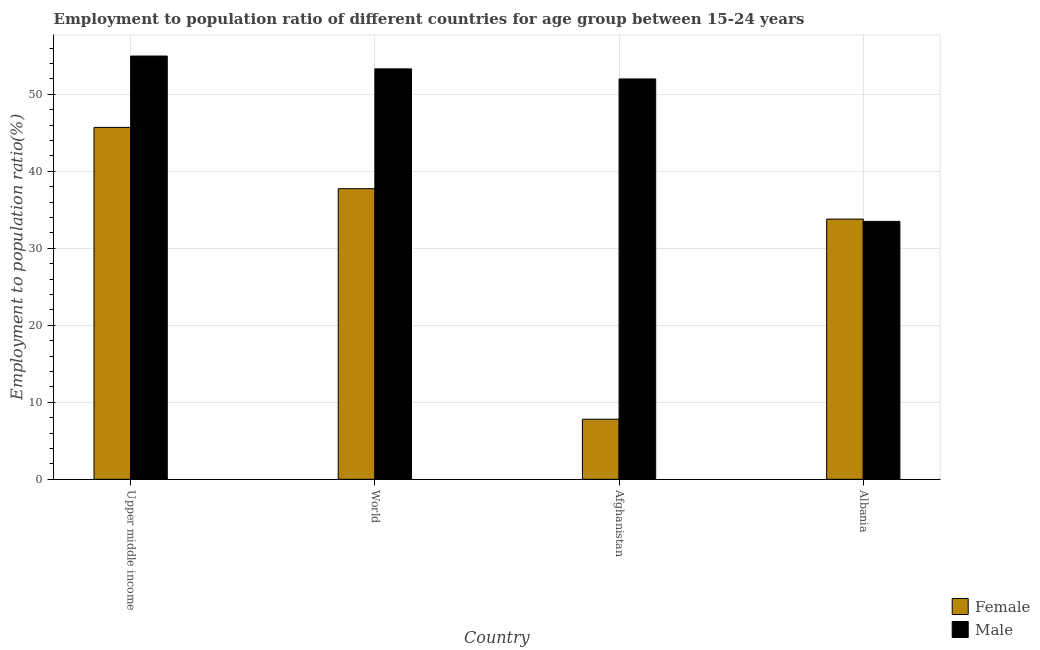How many groups of bars are there?
Make the answer very short. 4. Are the number of bars per tick equal to the number of legend labels?
Your answer should be very brief. Yes. How many bars are there on the 4th tick from the right?
Offer a terse response. 2. What is the label of the 3rd group of bars from the left?
Offer a terse response. Afghanistan. What is the employment to population ratio(male) in Afghanistan?
Ensure brevity in your answer.  52. Across all countries, what is the maximum employment to population ratio(female)?
Keep it short and to the point. 45.71. Across all countries, what is the minimum employment to population ratio(female)?
Your answer should be very brief. 7.8. In which country was the employment to population ratio(female) maximum?
Keep it short and to the point. Upper middle income. In which country was the employment to population ratio(male) minimum?
Offer a terse response. Albania. What is the total employment to population ratio(female) in the graph?
Your answer should be compact. 125.05. What is the difference between the employment to population ratio(female) in Afghanistan and that in Albania?
Offer a terse response. -26. What is the difference between the employment to population ratio(male) in Albania and the employment to population ratio(female) in World?
Provide a succinct answer. -4.25. What is the average employment to population ratio(male) per country?
Keep it short and to the point. 48.45. What is the difference between the employment to population ratio(female) and employment to population ratio(male) in World?
Ensure brevity in your answer.  -15.57. In how many countries, is the employment to population ratio(female) greater than 30 %?
Offer a very short reply. 3. What is the ratio of the employment to population ratio(female) in Albania to that in World?
Offer a very short reply. 0.9. Is the difference between the employment to population ratio(female) in Afghanistan and Upper middle income greater than the difference between the employment to population ratio(male) in Afghanistan and Upper middle income?
Ensure brevity in your answer.  No. What is the difference between the highest and the second highest employment to population ratio(female)?
Keep it short and to the point. 7.96. What is the difference between the highest and the lowest employment to population ratio(female)?
Keep it short and to the point. 37.91. In how many countries, is the employment to population ratio(female) greater than the average employment to population ratio(female) taken over all countries?
Provide a short and direct response. 3. Is the sum of the employment to population ratio(male) in Albania and World greater than the maximum employment to population ratio(female) across all countries?
Your response must be concise. Yes. What does the 2nd bar from the right in Albania represents?
Your answer should be very brief. Female. Are all the bars in the graph horizontal?
Give a very brief answer. No. How many countries are there in the graph?
Your response must be concise. 4. Does the graph contain any zero values?
Provide a short and direct response. No. Where does the legend appear in the graph?
Keep it short and to the point. Bottom right. What is the title of the graph?
Your answer should be very brief. Employment to population ratio of different countries for age group between 15-24 years. What is the label or title of the Y-axis?
Ensure brevity in your answer.  Employment to population ratio(%). What is the Employment to population ratio(%) in Female in Upper middle income?
Provide a succinct answer. 45.71. What is the Employment to population ratio(%) in Male in Upper middle income?
Your answer should be very brief. 54.98. What is the Employment to population ratio(%) in Female in World?
Provide a succinct answer. 37.75. What is the Employment to population ratio(%) in Male in World?
Provide a short and direct response. 53.31. What is the Employment to population ratio(%) of Female in Afghanistan?
Offer a very short reply. 7.8. What is the Employment to population ratio(%) in Male in Afghanistan?
Offer a very short reply. 52. What is the Employment to population ratio(%) of Female in Albania?
Give a very brief answer. 33.8. What is the Employment to population ratio(%) in Male in Albania?
Make the answer very short. 33.5. Across all countries, what is the maximum Employment to population ratio(%) in Female?
Your answer should be very brief. 45.71. Across all countries, what is the maximum Employment to population ratio(%) in Male?
Your response must be concise. 54.98. Across all countries, what is the minimum Employment to population ratio(%) of Female?
Ensure brevity in your answer.  7.8. Across all countries, what is the minimum Employment to population ratio(%) of Male?
Your answer should be compact. 33.5. What is the total Employment to population ratio(%) of Female in the graph?
Give a very brief answer. 125.05. What is the total Employment to population ratio(%) in Male in the graph?
Your answer should be very brief. 193.79. What is the difference between the Employment to population ratio(%) in Female in Upper middle income and that in World?
Offer a terse response. 7.96. What is the difference between the Employment to population ratio(%) of Male in Upper middle income and that in World?
Your response must be concise. 1.67. What is the difference between the Employment to population ratio(%) in Female in Upper middle income and that in Afghanistan?
Offer a very short reply. 37.91. What is the difference between the Employment to population ratio(%) of Male in Upper middle income and that in Afghanistan?
Offer a very short reply. 2.98. What is the difference between the Employment to population ratio(%) of Female in Upper middle income and that in Albania?
Keep it short and to the point. 11.91. What is the difference between the Employment to population ratio(%) of Male in Upper middle income and that in Albania?
Provide a short and direct response. 21.48. What is the difference between the Employment to population ratio(%) in Female in World and that in Afghanistan?
Keep it short and to the point. 29.95. What is the difference between the Employment to population ratio(%) of Male in World and that in Afghanistan?
Make the answer very short. 1.31. What is the difference between the Employment to population ratio(%) of Female in World and that in Albania?
Give a very brief answer. 3.95. What is the difference between the Employment to population ratio(%) of Male in World and that in Albania?
Make the answer very short. 19.81. What is the difference between the Employment to population ratio(%) of Female in Afghanistan and that in Albania?
Make the answer very short. -26. What is the difference between the Employment to population ratio(%) of Male in Afghanistan and that in Albania?
Your answer should be compact. 18.5. What is the difference between the Employment to population ratio(%) of Female in Upper middle income and the Employment to population ratio(%) of Male in World?
Give a very brief answer. -7.6. What is the difference between the Employment to population ratio(%) in Female in Upper middle income and the Employment to population ratio(%) in Male in Afghanistan?
Offer a very short reply. -6.29. What is the difference between the Employment to population ratio(%) of Female in Upper middle income and the Employment to population ratio(%) of Male in Albania?
Your answer should be compact. 12.21. What is the difference between the Employment to population ratio(%) of Female in World and the Employment to population ratio(%) of Male in Afghanistan?
Provide a succinct answer. -14.25. What is the difference between the Employment to population ratio(%) in Female in World and the Employment to population ratio(%) in Male in Albania?
Make the answer very short. 4.25. What is the difference between the Employment to population ratio(%) of Female in Afghanistan and the Employment to population ratio(%) of Male in Albania?
Your answer should be very brief. -25.7. What is the average Employment to population ratio(%) of Female per country?
Offer a terse response. 31.26. What is the average Employment to population ratio(%) in Male per country?
Provide a short and direct response. 48.45. What is the difference between the Employment to population ratio(%) of Female and Employment to population ratio(%) of Male in Upper middle income?
Offer a terse response. -9.27. What is the difference between the Employment to population ratio(%) of Female and Employment to population ratio(%) of Male in World?
Give a very brief answer. -15.57. What is the difference between the Employment to population ratio(%) of Female and Employment to population ratio(%) of Male in Afghanistan?
Keep it short and to the point. -44.2. What is the ratio of the Employment to population ratio(%) of Female in Upper middle income to that in World?
Your answer should be very brief. 1.21. What is the ratio of the Employment to population ratio(%) in Male in Upper middle income to that in World?
Offer a terse response. 1.03. What is the ratio of the Employment to population ratio(%) in Female in Upper middle income to that in Afghanistan?
Provide a short and direct response. 5.86. What is the ratio of the Employment to population ratio(%) in Male in Upper middle income to that in Afghanistan?
Your answer should be compact. 1.06. What is the ratio of the Employment to population ratio(%) of Female in Upper middle income to that in Albania?
Ensure brevity in your answer.  1.35. What is the ratio of the Employment to population ratio(%) of Male in Upper middle income to that in Albania?
Provide a succinct answer. 1.64. What is the ratio of the Employment to population ratio(%) of Female in World to that in Afghanistan?
Your response must be concise. 4.84. What is the ratio of the Employment to population ratio(%) in Male in World to that in Afghanistan?
Provide a short and direct response. 1.03. What is the ratio of the Employment to population ratio(%) of Female in World to that in Albania?
Make the answer very short. 1.12. What is the ratio of the Employment to population ratio(%) of Male in World to that in Albania?
Your answer should be compact. 1.59. What is the ratio of the Employment to population ratio(%) in Female in Afghanistan to that in Albania?
Your answer should be compact. 0.23. What is the ratio of the Employment to population ratio(%) of Male in Afghanistan to that in Albania?
Offer a terse response. 1.55. What is the difference between the highest and the second highest Employment to population ratio(%) of Female?
Offer a terse response. 7.96. What is the difference between the highest and the second highest Employment to population ratio(%) of Male?
Ensure brevity in your answer.  1.67. What is the difference between the highest and the lowest Employment to population ratio(%) of Female?
Make the answer very short. 37.91. What is the difference between the highest and the lowest Employment to population ratio(%) in Male?
Offer a very short reply. 21.48. 